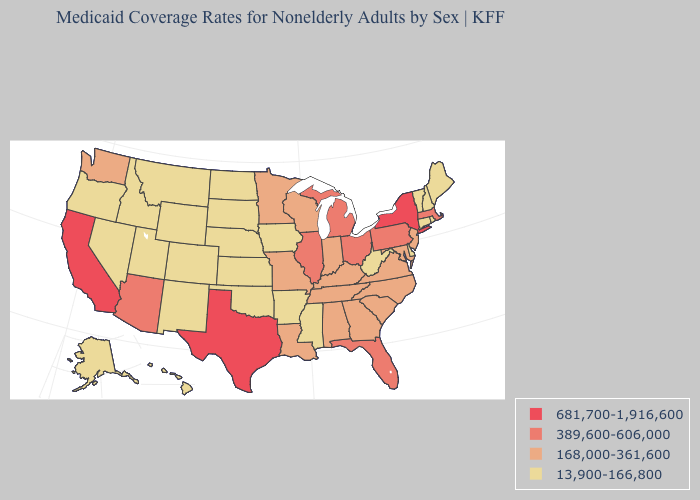Name the states that have a value in the range 13,900-166,800?
Give a very brief answer. Alaska, Arkansas, Colorado, Connecticut, Delaware, Hawaii, Idaho, Iowa, Kansas, Maine, Mississippi, Montana, Nebraska, Nevada, New Hampshire, New Mexico, North Dakota, Oklahoma, Oregon, Rhode Island, South Dakota, Utah, Vermont, West Virginia, Wyoming. Name the states that have a value in the range 389,600-606,000?
Write a very short answer. Arizona, Florida, Illinois, Massachusetts, Michigan, Ohio, Pennsylvania. Name the states that have a value in the range 13,900-166,800?
Keep it brief. Alaska, Arkansas, Colorado, Connecticut, Delaware, Hawaii, Idaho, Iowa, Kansas, Maine, Mississippi, Montana, Nebraska, Nevada, New Hampshire, New Mexico, North Dakota, Oklahoma, Oregon, Rhode Island, South Dakota, Utah, Vermont, West Virginia, Wyoming. Which states have the lowest value in the MidWest?
Be succinct. Iowa, Kansas, Nebraska, North Dakota, South Dakota. What is the value of Tennessee?
Quick response, please. 168,000-361,600. Among the states that border California , which have the lowest value?
Short answer required. Nevada, Oregon. What is the highest value in the USA?
Write a very short answer. 681,700-1,916,600. What is the value of Maine?
Quick response, please. 13,900-166,800. What is the lowest value in states that border Montana?
Give a very brief answer. 13,900-166,800. Among the states that border Arkansas , does Mississippi have the lowest value?
Quick response, please. Yes. What is the value of Montana?
Answer briefly. 13,900-166,800. Does California have the highest value in the West?
Concise answer only. Yes. Does Indiana have a higher value than Maine?
Be succinct. Yes. What is the value of Maryland?
Answer briefly. 168,000-361,600. 